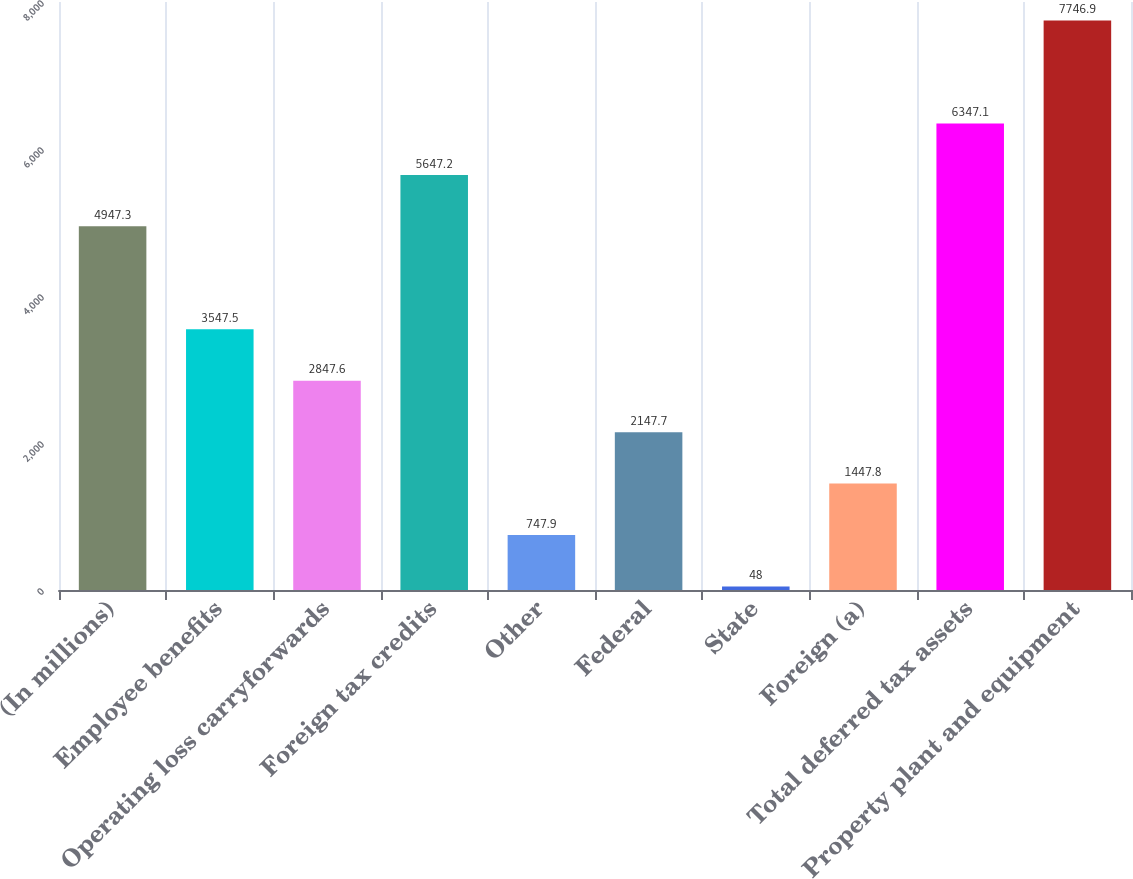<chart> <loc_0><loc_0><loc_500><loc_500><bar_chart><fcel>(In millions)<fcel>Employee benefits<fcel>Operating loss carryforwards<fcel>Foreign tax credits<fcel>Other<fcel>Federal<fcel>State<fcel>Foreign (a)<fcel>Total deferred tax assets<fcel>Property plant and equipment<nl><fcel>4947.3<fcel>3547.5<fcel>2847.6<fcel>5647.2<fcel>747.9<fcel>2147.7<fcel>48<fcel>1447.8<fcel>6347.1<fcel>7746.9<nl></chart> 